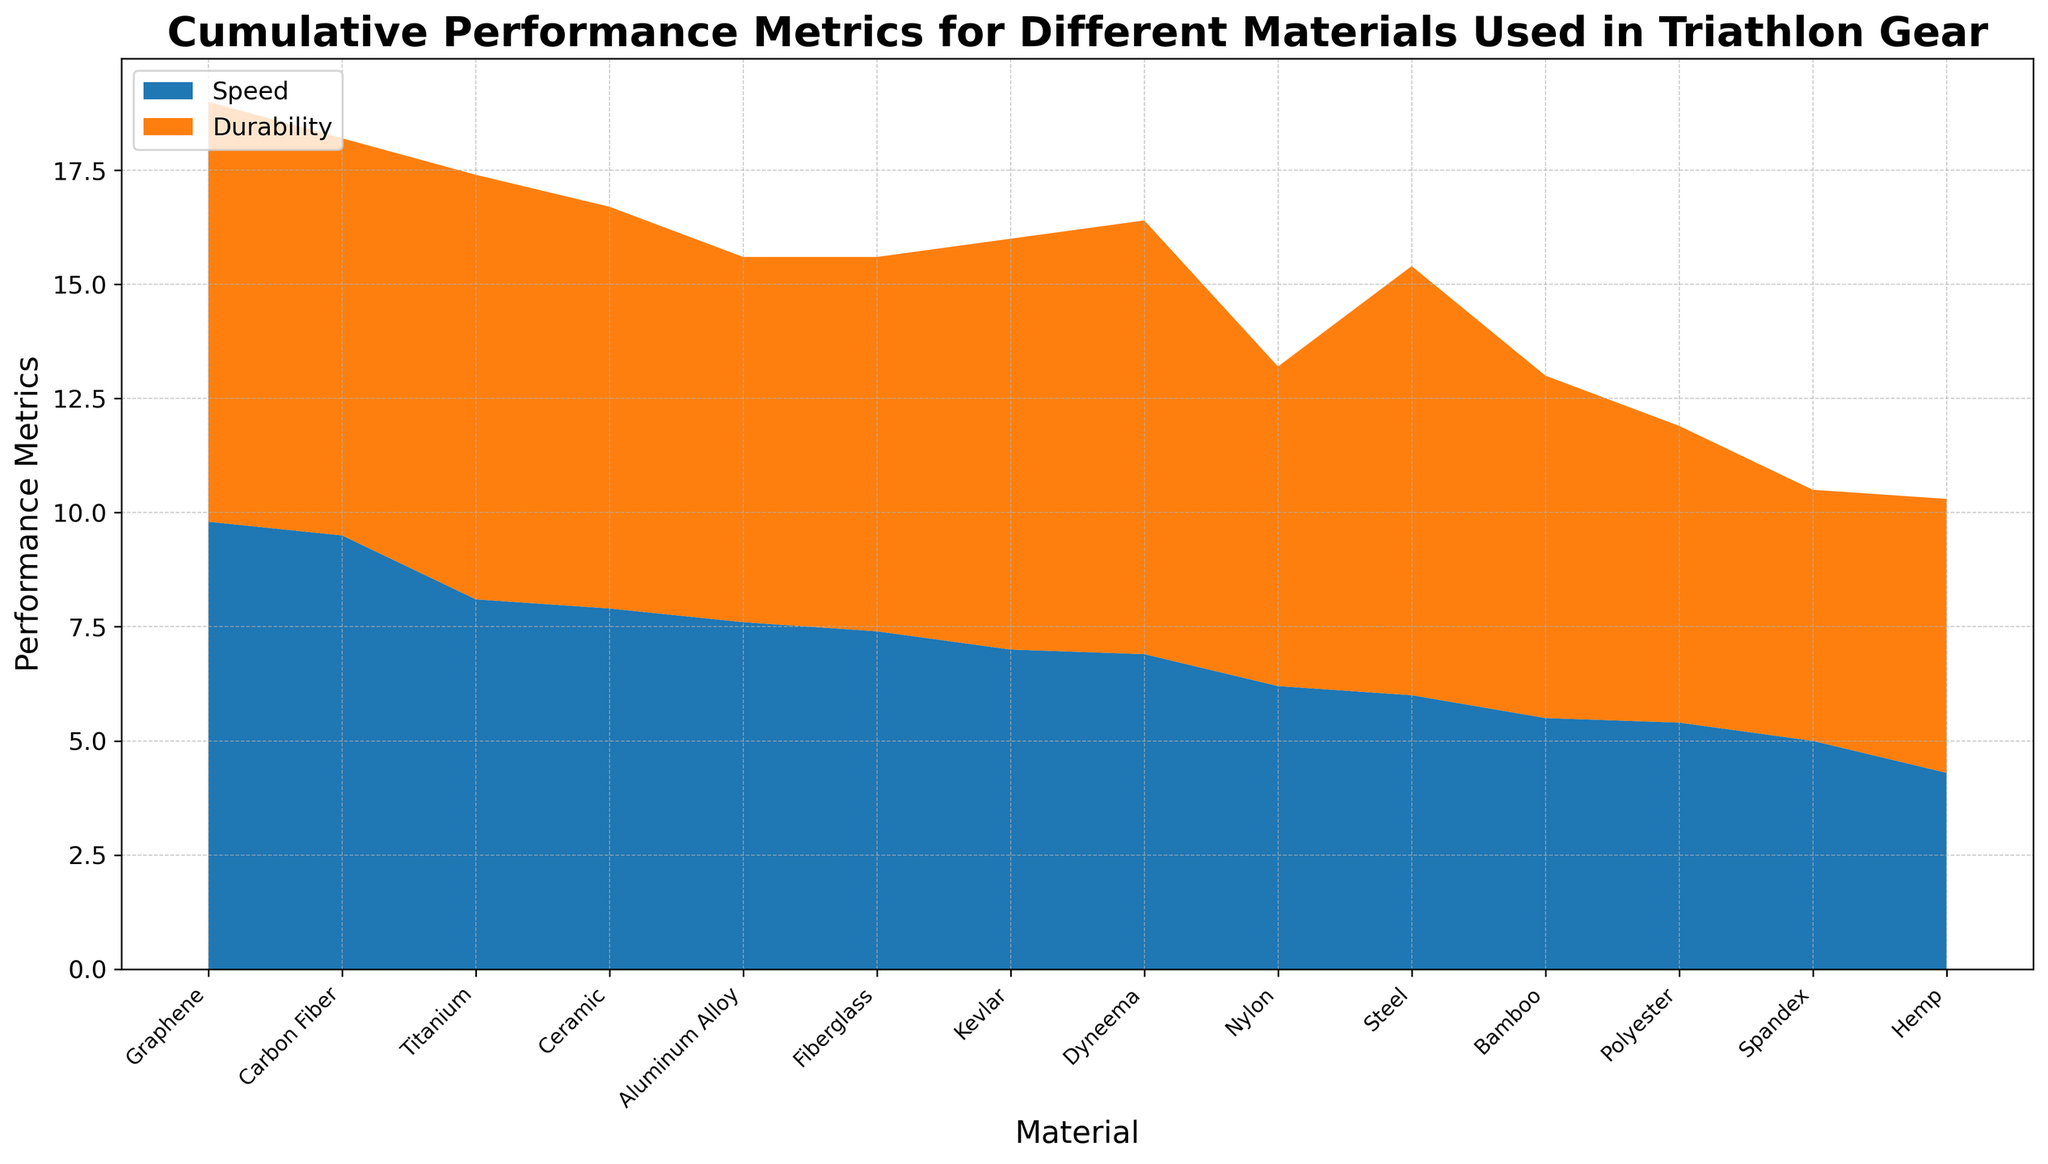What material has the highest cumulative performance metric for speed? By observing the height of the blue area in the area chart, we can identify that Graphene reaches the highest point for speed.
Answer: Graphene How does the speed of Kevlar compare to the speed of Titanium? Looking at the area chart, Kevlar's blue section is shorter than Titanium's, indicating that Kevlar has a lower speed metric compared to Titanium.
Answer: Kevlar has a lower speed Which material shows the smallest cumulative performance metric for durability? By observing the combined height of the orange area, Hemp has the smallest section, indicating the lowest durability.
Answer: Hemp What is the total performance metric (speed + durability) for Carbon Fiber? Add the height of both metrics (Speed 9.5 and Durability 8.7). So, total performance is 9.5 + 8.7 = 18.2.
Answer: 18.2 Which material has nearly equal performance metrics for both speed and durability? Visual inspection reveals that Nylon’s speed (6.2) and durability (7.0) are relatively close compared to other materials.
Answer: Nylon At what point does the speed metric exceed 8 for the first time? By observing the height of the chart, Graphene, Carbon Fiber, and Titanium speed metrics exceed 8. Among these, Graphene’s section comes first as it is sorted by speed.
Answer: Graphene Among Kevlar, Dyneema, and Kevlar, which has the highest metric in durability? By comparing the height of the orange areas, Dyneema's durability section is the tallest among the three materials.
Answer: Dyneema Rank the top three materials by speed. By inspecting the blue areas from tallest to shortest, the top three materials by speed are: Graphene, Carbon Fiber, Titanium.
Answer: 1. Graphene 2. Carbon Fiber 3. Titanium Are there any materials with a speed metric lower than 5? All blue sections can be inspected; Spandex and Hemp fall below the 5-mark in their speed sections.
Answer: Yes, Spandex and Hemp How does the combined performance metric of Bamboo compare to Fiberglass? By adding the values of speed and durability for each: Bamboo (5.5 + 7.5 = 13), Fiberglass (7.4 + 8.2 = 15.6); therefore, Fiberglass has a higher combined metric than Bamboo.
Answer: Fiberglass has a higher combined metric 